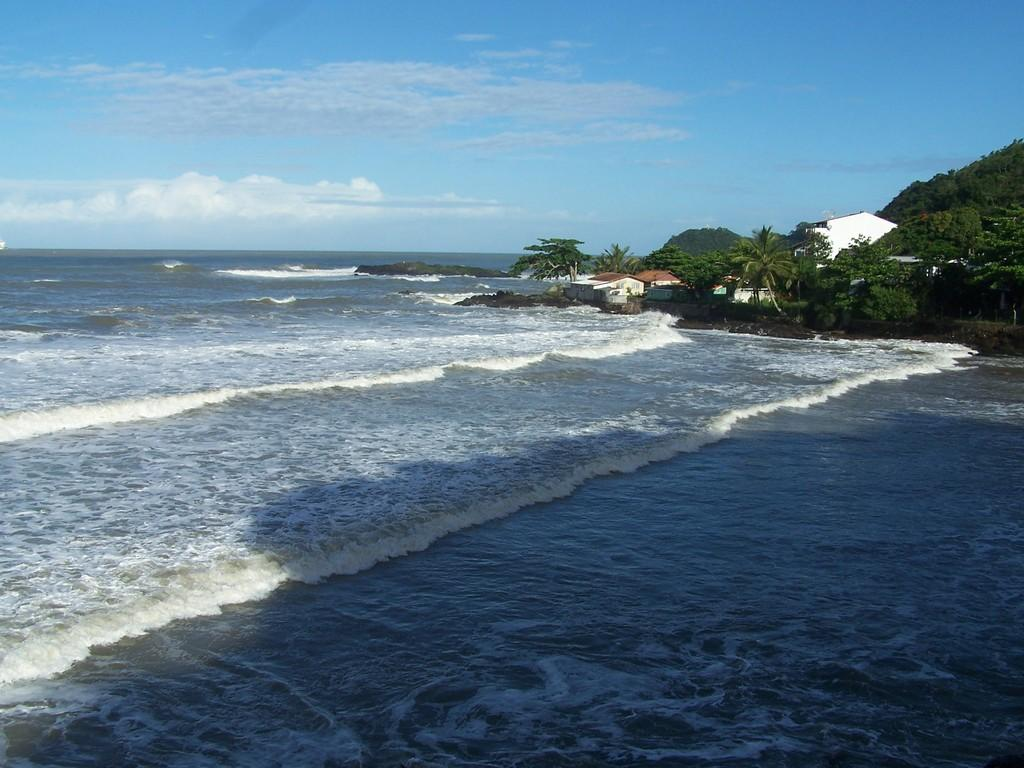What type of natural feature is present in the image? There is a river in the image. What can be seen in the background of the image? There are trees and buildings in the background of the image. What is visible in the sky in the image? The sky is visible in the background of the image. What type of marble can be seen in the image? There is no marble present in the image. Is there a jail visible in the image? There is no jail present in the image. What type of amusement can be seen in the image? There is no amusement present in the image. 